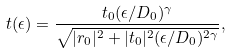Convert formula to latex. <formula><loc_0><loc_0><loc_500><loc_500>t ( \epsilon ) = \frac { t _ { 0 } ( \epsilon / D _ { 0 } ) ^ { \gamma } } { \sqrt { | r _ { 0 } | ^ { 2 } + | t _ { 0 } | ^ { 2 } ( \epsilon / D _ { 0 } ) ^ { 2 \gamma } } } ,</formula> 